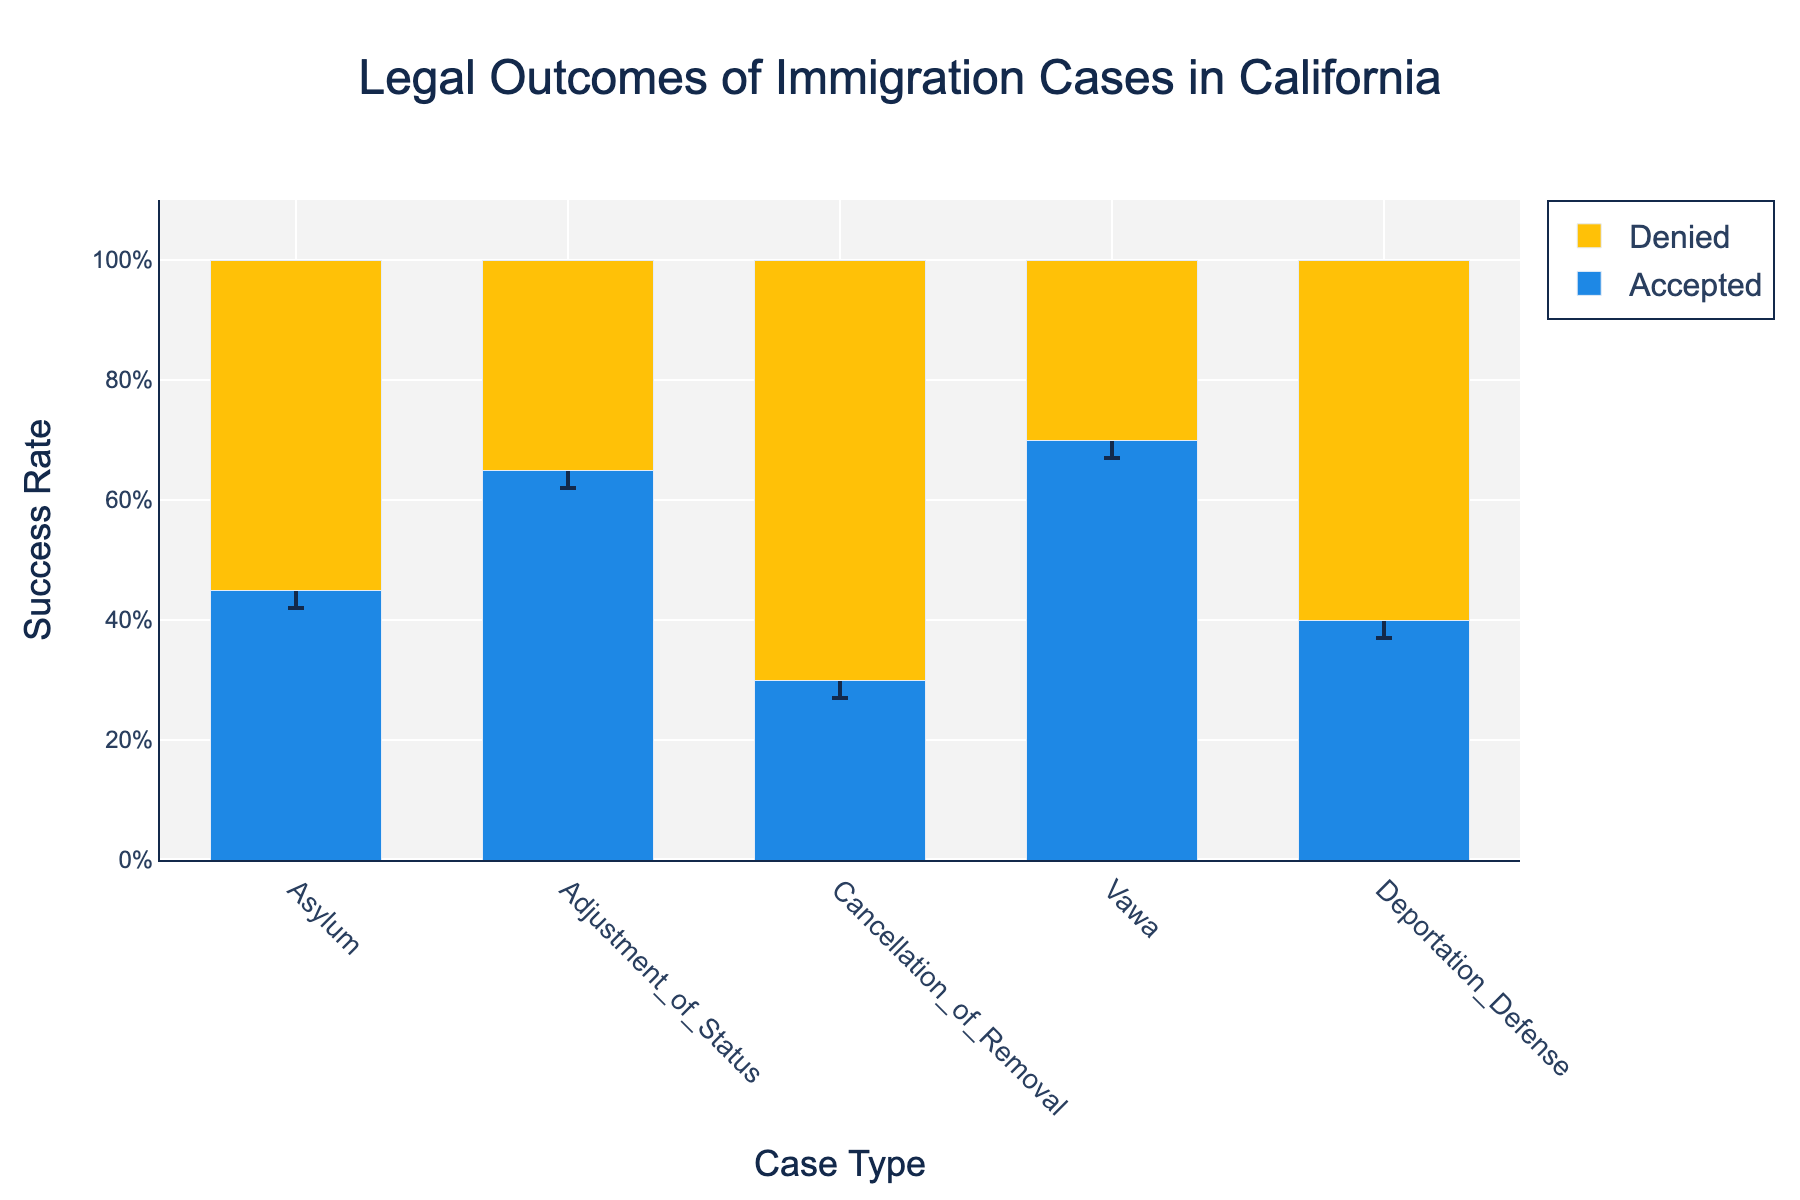What's the title of the figure? The title of the figure is located at the top of the plot and it reads "Legal Outcomes of Immigration Cases in California"
Answer: Legal Outcomes of Immigration Cases in California Which case type has the highest success rate for accepted cases? By looking at the peak bars for the 'Accepted' category, the Adjustment of Status case type has the highest bar, indicating the highest success rate
Answer: Adjustment of Status What is the range of the success rate for Asylum cases that were accepted? The range can be found by subtracting the lower confidence interval from the upper confidence interval. For Asylum cases, the success rate ranges from 0.42 to 0.48
Answer: 0.06 How does the success rate of Deportation Defense cases compare to Asylum cases for accepted outcomes? Comparing the heights of the bars for Deportation Defense and Asylum in the Accepted outcome category shows that Deportation Defense has a lower success rate than Asylum
Answer: Deportation Defense has a lower success rate Which case type shows the largest difference between accepted and denied rates? By observing the difference between the Accepted and Denied bars for each case type, Cancellation of Removal shows the largest gap
Answer: Cancellation of Removal Does any case type have the same success rate for both accepted and denied outcomes? By inspecting each pair of bars, no case type has the same height bars for both Accepted and Denied outcomes
Answer: No Which case type has a higher success rate for accepted VAWA cases than deportation defense accepted cases? By comparing the heights of the 'Accepted' bars for VAWA and Deportation Defense, VAWA cases have higher success rates
Answer: VAWA How many case types have over 50% success rate for accepted outcomes? Looking at the heights of the 'Accepted' bars, three case types—Adjustment of Status, VAWA, and Deportation Defense—have visible bars above the 50% mark
Answer: Three Between Asylum and Cancellation of Removal, which case type has a higher success rate for accepted outcomes? Comparing the heights of the 'Accepted' bars for both case types, Asylum shows a higher success rate
Answer: Asylum What's the difference in success rate for denied outcomes between Deportation Defense and VAWA cases? Subtract the height of the 'Denied' bar for VAWA from the 'Denied' bar for Deportation Defense; 0.60 - 0.30 = 0.30
Answer: 0.30 